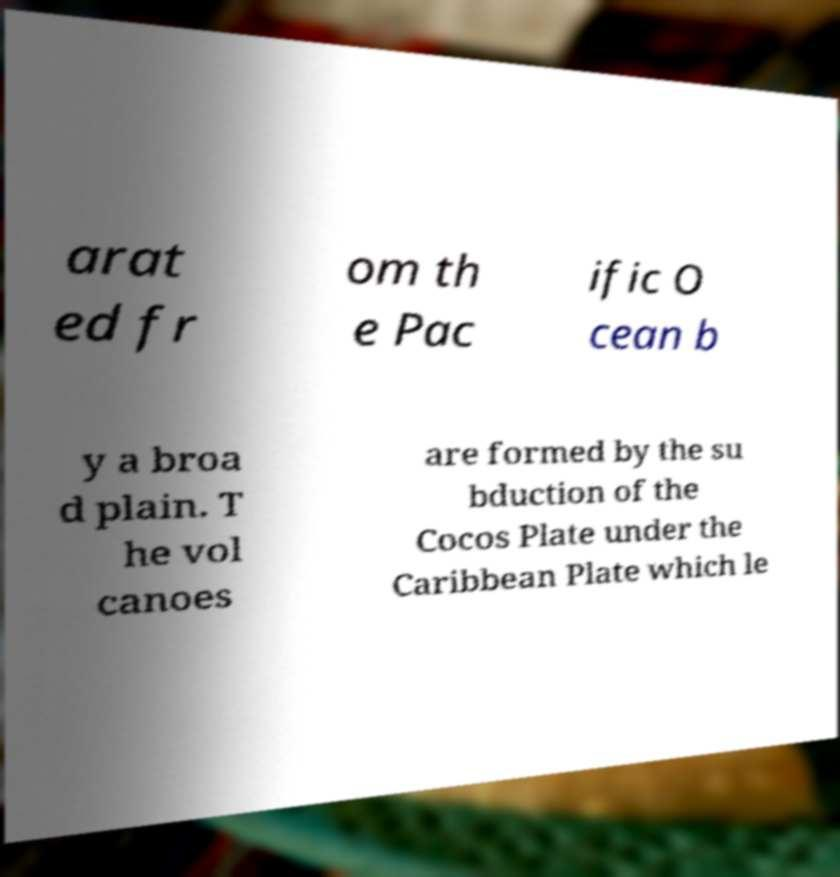For documentation purposes, I need the text within this image transcribed. Could you provide that? arat ed fr om th e Pac ific O cean b y a broa d plain. T he vol canoes are formed by the su bduction of the Cocos Plate under the Caribbean Plate which le 